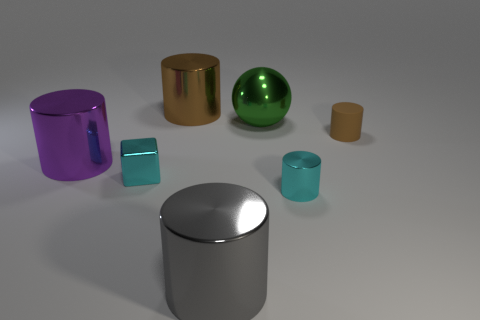Subtract all small cyan metallic cylinders. How many cylinders are left? 4 Add 1 metallic cubes. How many objects exist? 8 Subtract all green cubes. How many brown cylinders are left? 2 Subtract 1 blocks. How many blocks are left? 0 Subtract all cyan cylinders. How many cylinders are left? 4 Subtract all spheres. How many objects are left? 6 Subtract all tiny green metallic things. Subtract all small brown cylinders. How many objects are left? 6 Add 7 green things. How many green things are left? 8 Add 7 brown cylinders. How many brown cylinders exist? 9 Subtract 0 gray blocks. How many objects are left? 7 